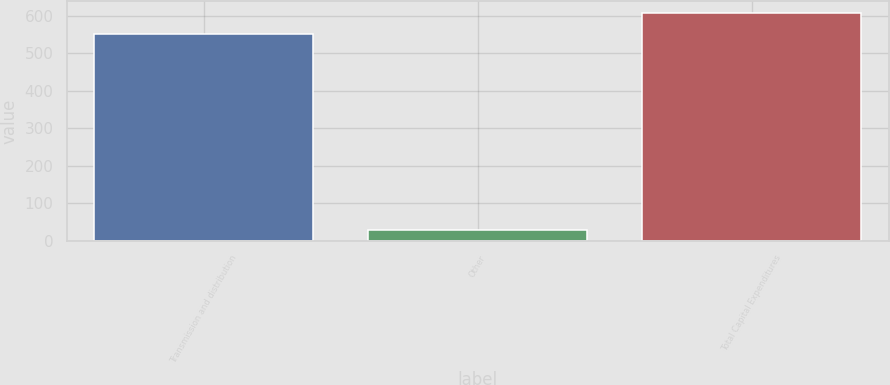Convert chart to OTSL. <chart><loc_0><loc_0><loc_500><loc_500><bar_chart><fcel>Transmission and distribution<fcel>Other<fcel>Total Capital Expenditures<nl><fcel>553<fcel>29<fcel>608.3<nl></chart> 